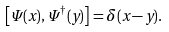<formula> <loc_0><loc_0><loc_500><loc_500>\left [ \Psi ( x ) , \Psi ^ { \dag } ( y ) \right ] = \delta ( x - y ) .</formula> 